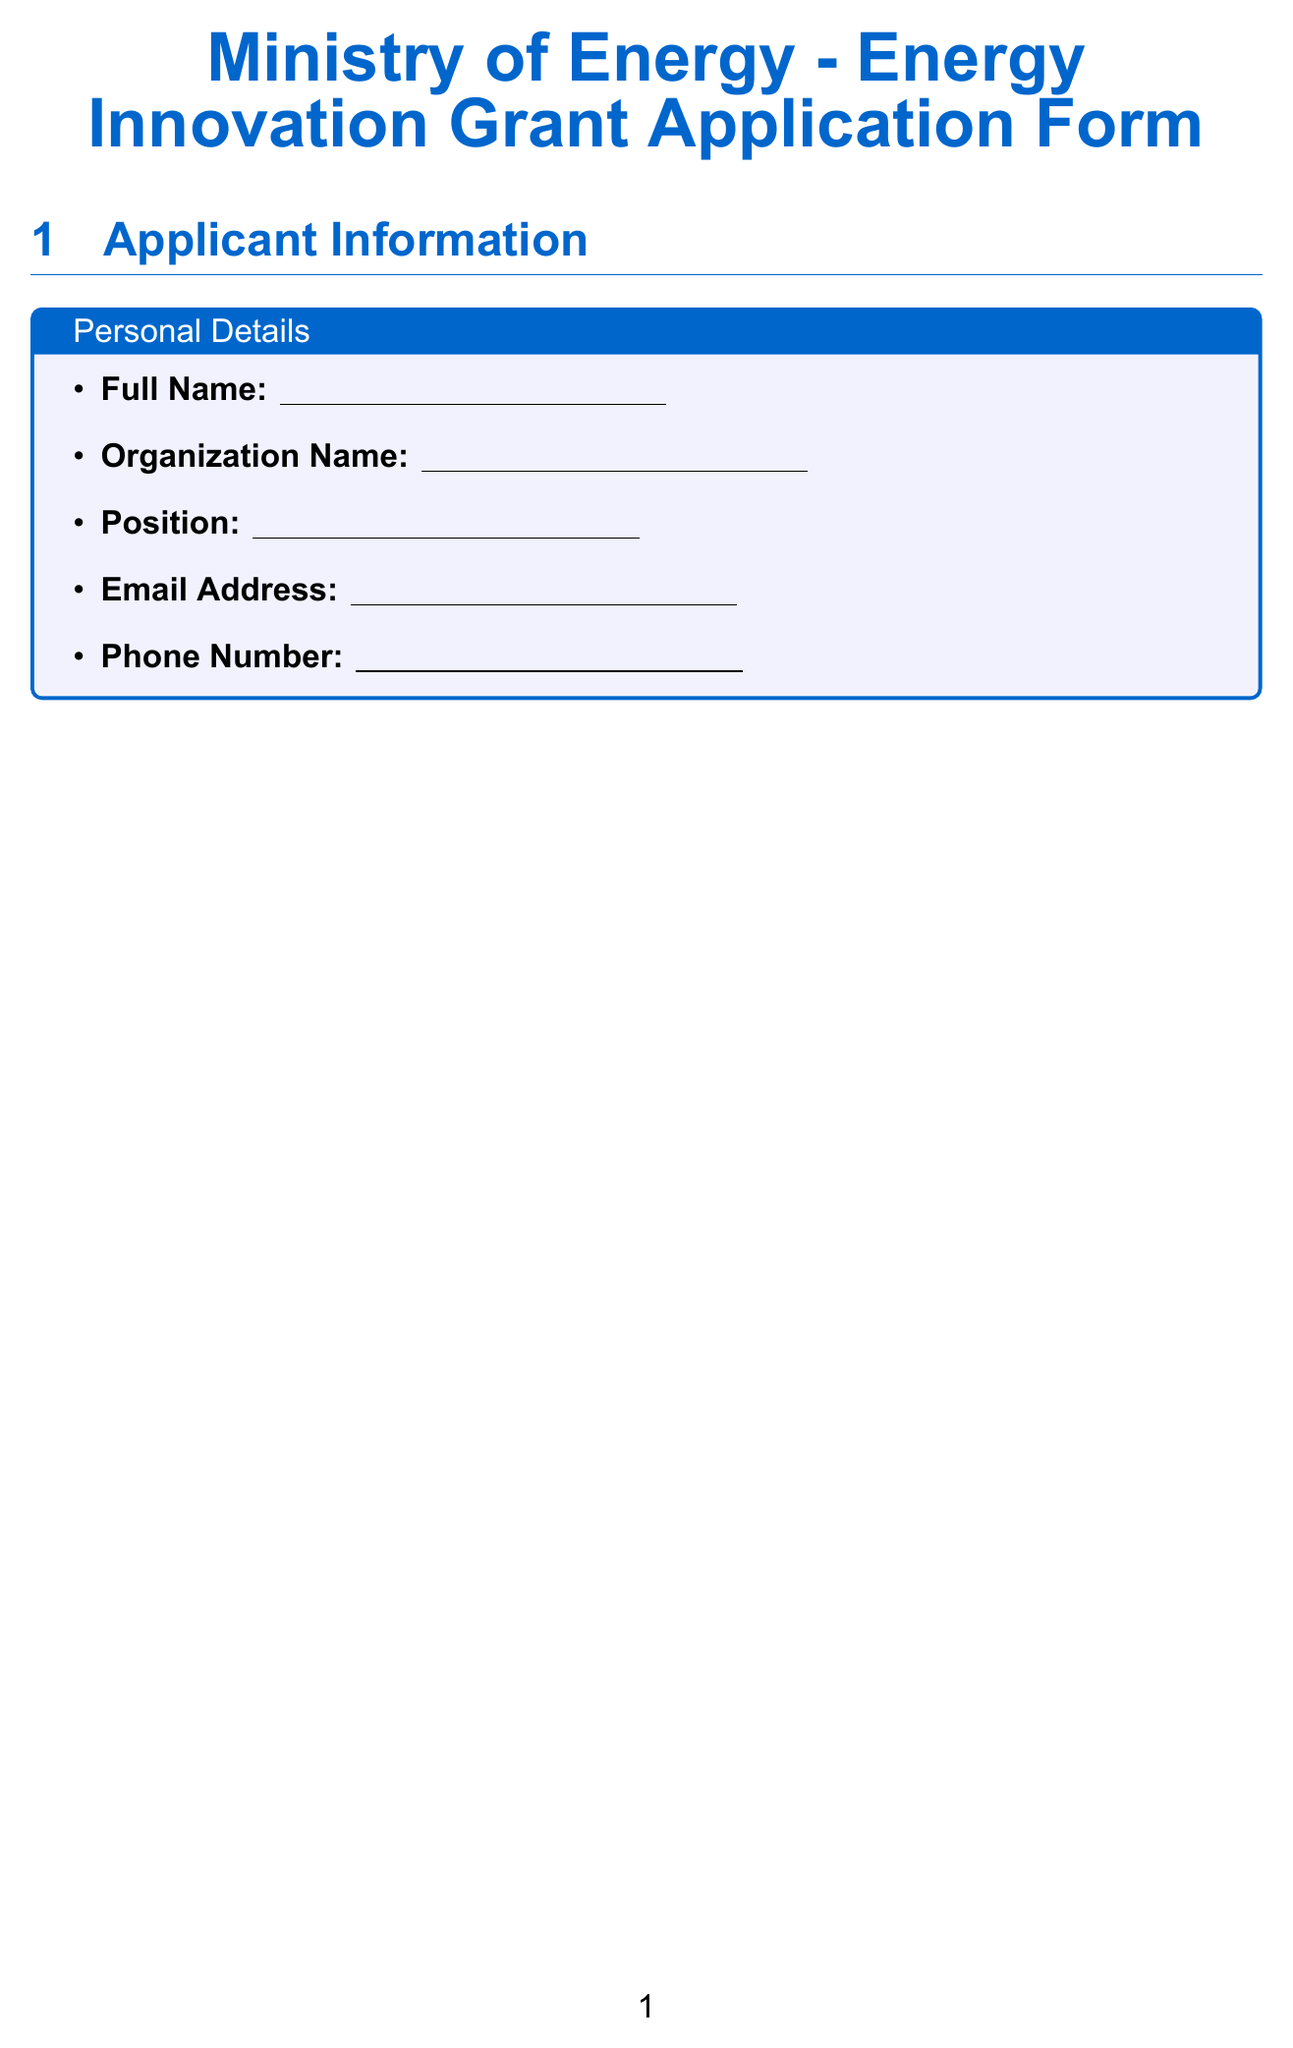What is the total budget requested? The total budget requested is stated in the budget section of the form.
Answer: Total budget requested (in local currency) What is the maximum word count for the project summary? The maximum word count for the project summary is specified in the project details section.
Answer: 300 words List one targeted energy source mentioned in the document. One example of a targeted energy source can be found in the targeted energy source section.
Answer: Solar How many project objectives can be listed? The maximum number of project objectives that can be listed is indicated in the project objectives section.
Answer: 5 What is required in the sustainability section of the document? The sustainability section requires explanations of long-term viability, job creation, and community benefits.
Answer: Long-term viability, job creation, community benefits Describe the purpose of the certification section. The certification section is included for the applicant to affirm that all information is true and accurate.
Answer: Certify truth and accuracy What types of partners should be listed in the partnership section? The partnership and collaboration section specifies that partnerships or collaborators involved in the project should be identified.
Answer: Partners or collaborators What is the maximum word count for the innovation description? The maximum word count for the innovation description is specified in the technical details section of the form.
Answer: 1000 words 